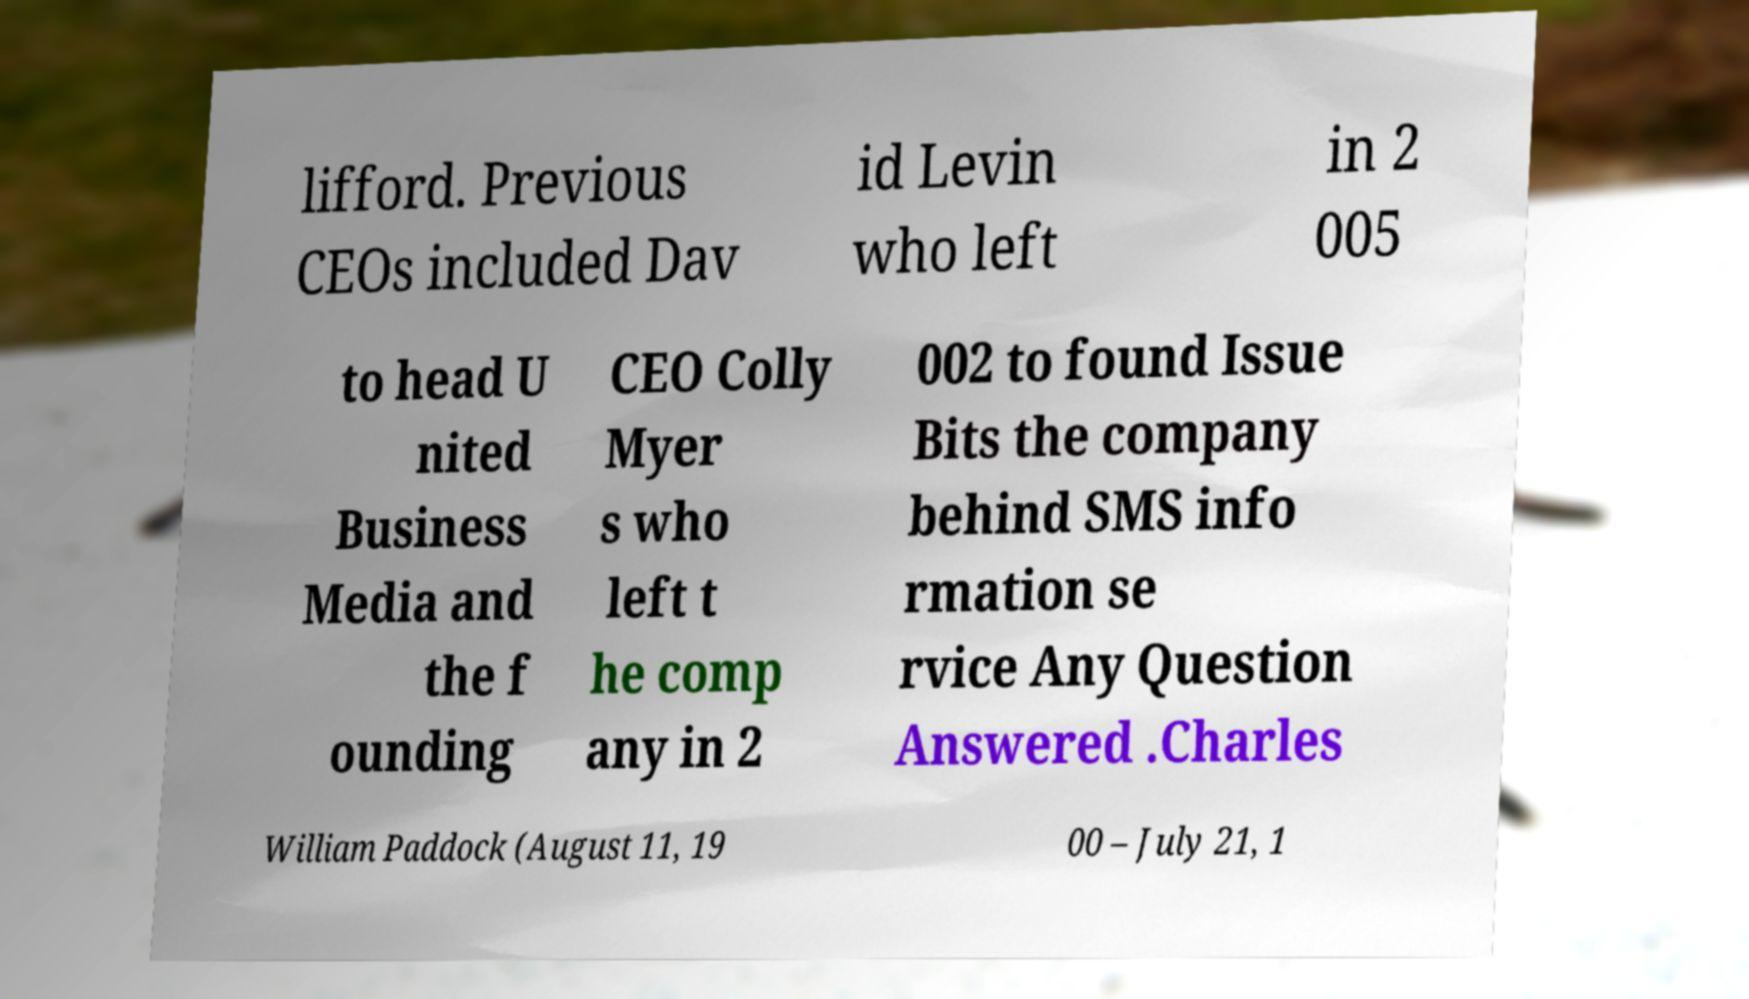Can you accurately transcribe the text from the provided image for me? lifford. Previous CEOs included Dav id Levin who left in 2 005 to head U nited Business Media and the f ounding CEO Colly Myer s who left t he comp any in 2 002 to found Issue Bits the company behind SMS info rmation se rvice Any Question Answered .Charles William Paddock (August 11, 19 00 – July 21, 1 